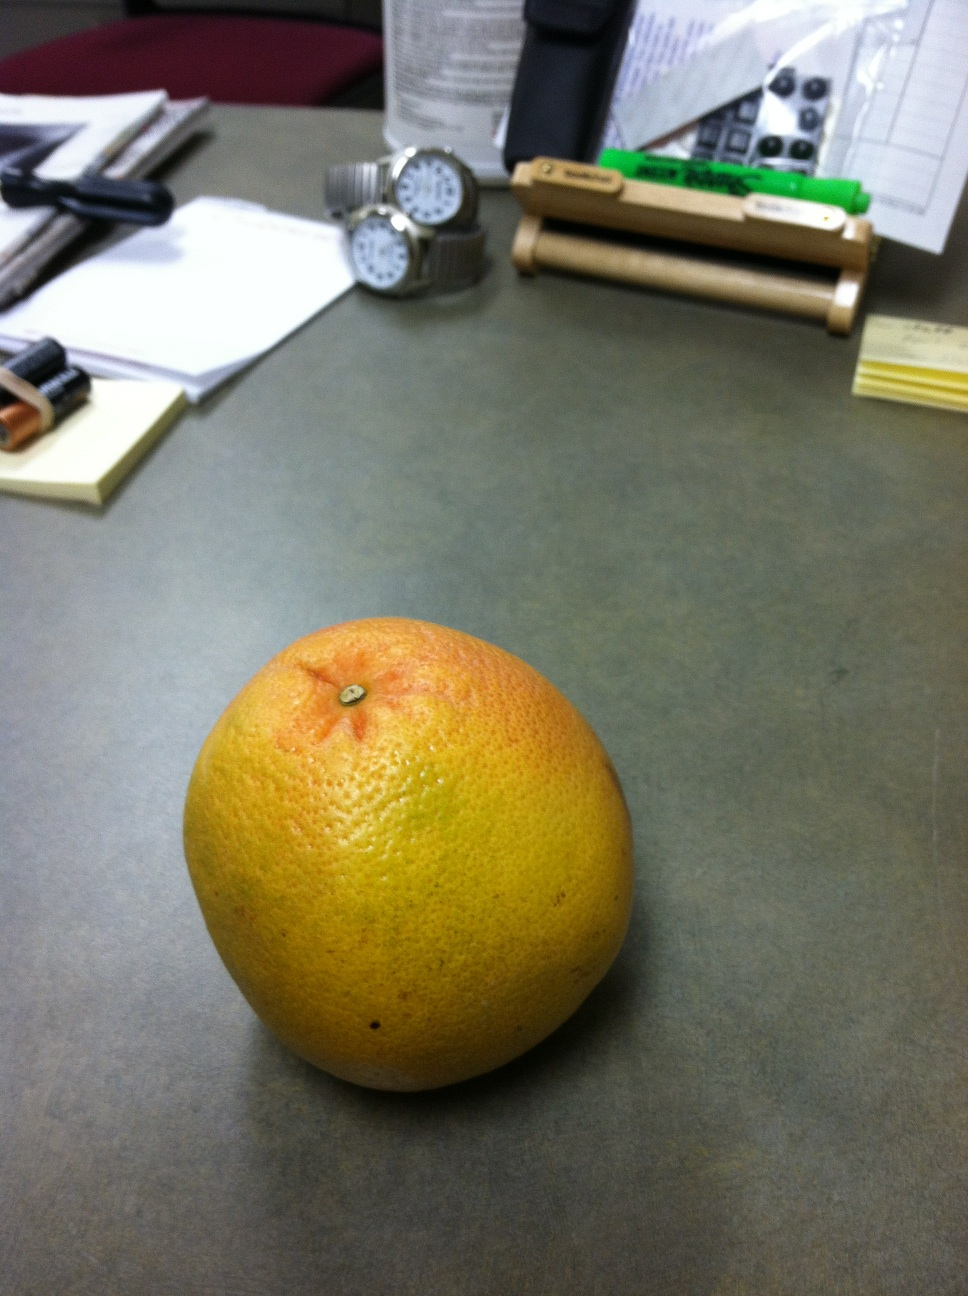Describe what you see on the desk in detail. On the desk, there is a grapefruit that exhibits a mix of orange and yellow colors with some red tinges. Surrounding it are various office items including two watches with metal bands, a couple of batteries, a few stacks of papers, sticky notes, a pen, and some office supplies. The desk surface appears to be a greyish color, and there is a padded chair in the background. What do you think this desk setup indicates about the person who uses it? The desk setup suggests a person who is organized but also busy. The presence of watches indicates punctuality or a need to manage time efficiently. The papers may signify ongoing work or projects that require attention. The neatly arranged office supplies suggest a structured approach to their tasks. Additionally, the grapefruit could imply that this individual values healthy snacking options. 